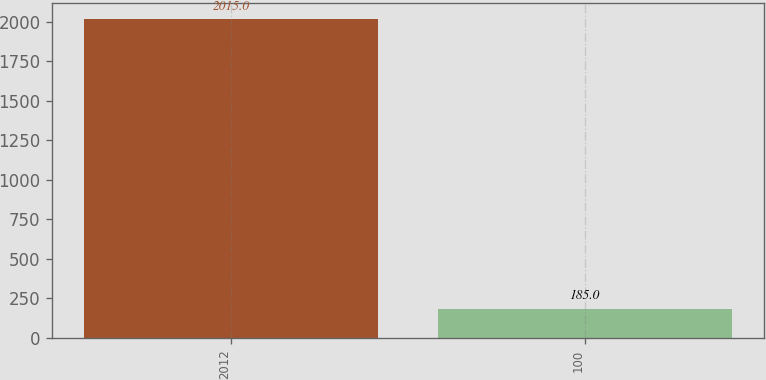Convert chart. <chart><loc_0><loc_0><loc_500><loc_500><bar_chart><fcel>2012<fcel>100<nl><fcel>2015<fcel>185<nl></chart> 